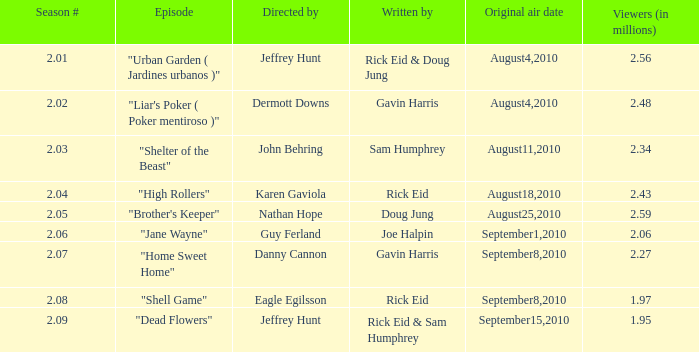For a season number of 2.08, what is the lowest value in the series? 18.0. 